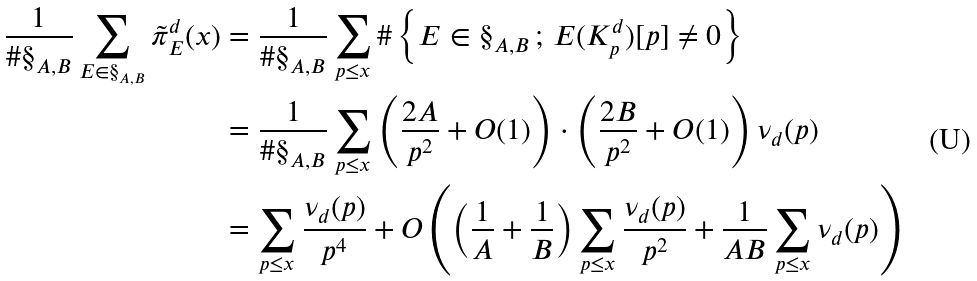<formula> <loc_0><loc_0><loc_500><loc_500>\frac { 1 } { \# \S _ { A , B } } \sum _ { E \in \S _ { A , B } } \tilde { \pi } _ { E } ^ { d } ( x ) & = \frac { 1 } { \# \S _ { A , B } } \sum _ { p \leq x } \# \left \{ E \in \S _ { A , B } \, ; \, E ( K _ { p } ^ { d } ) [ p ] \neq 0 \right \} \\ & = \frac { 1 } { \# \S _ { A , B } } \sum _ { p \leq x } \left ( \frac { 2 A } { p ^ { 2 } } + O ( 1 ) \right ) \cdot \left ( \frac { 2 B } { p ^ { 2 } } + O ( 1 ) \right ) \nu _ { d } ( p ) \\ & = \sum _ { p \leq x } \frac { \nu _ { d } ( p ) } { p ^ { 4 } } + O \left ( \left ( \frac { 1 } { A } + \frac { 1 } { B } \right ) \sum _ { p \leq x } \frac { \nu _ { d } ( p ) } { p ^ { 2 } } + \frac { 1 } { A B } \sum _ { p \leq x } \nu _ { d } ( p ) \right )</formula> 